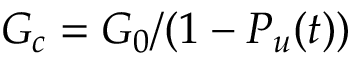<formula> <loc_0><loc_0><loc_500><loc_500>G _ { c } = G _ { 0 } / ( 1 - P _ { u } ( t ) )</formula> 